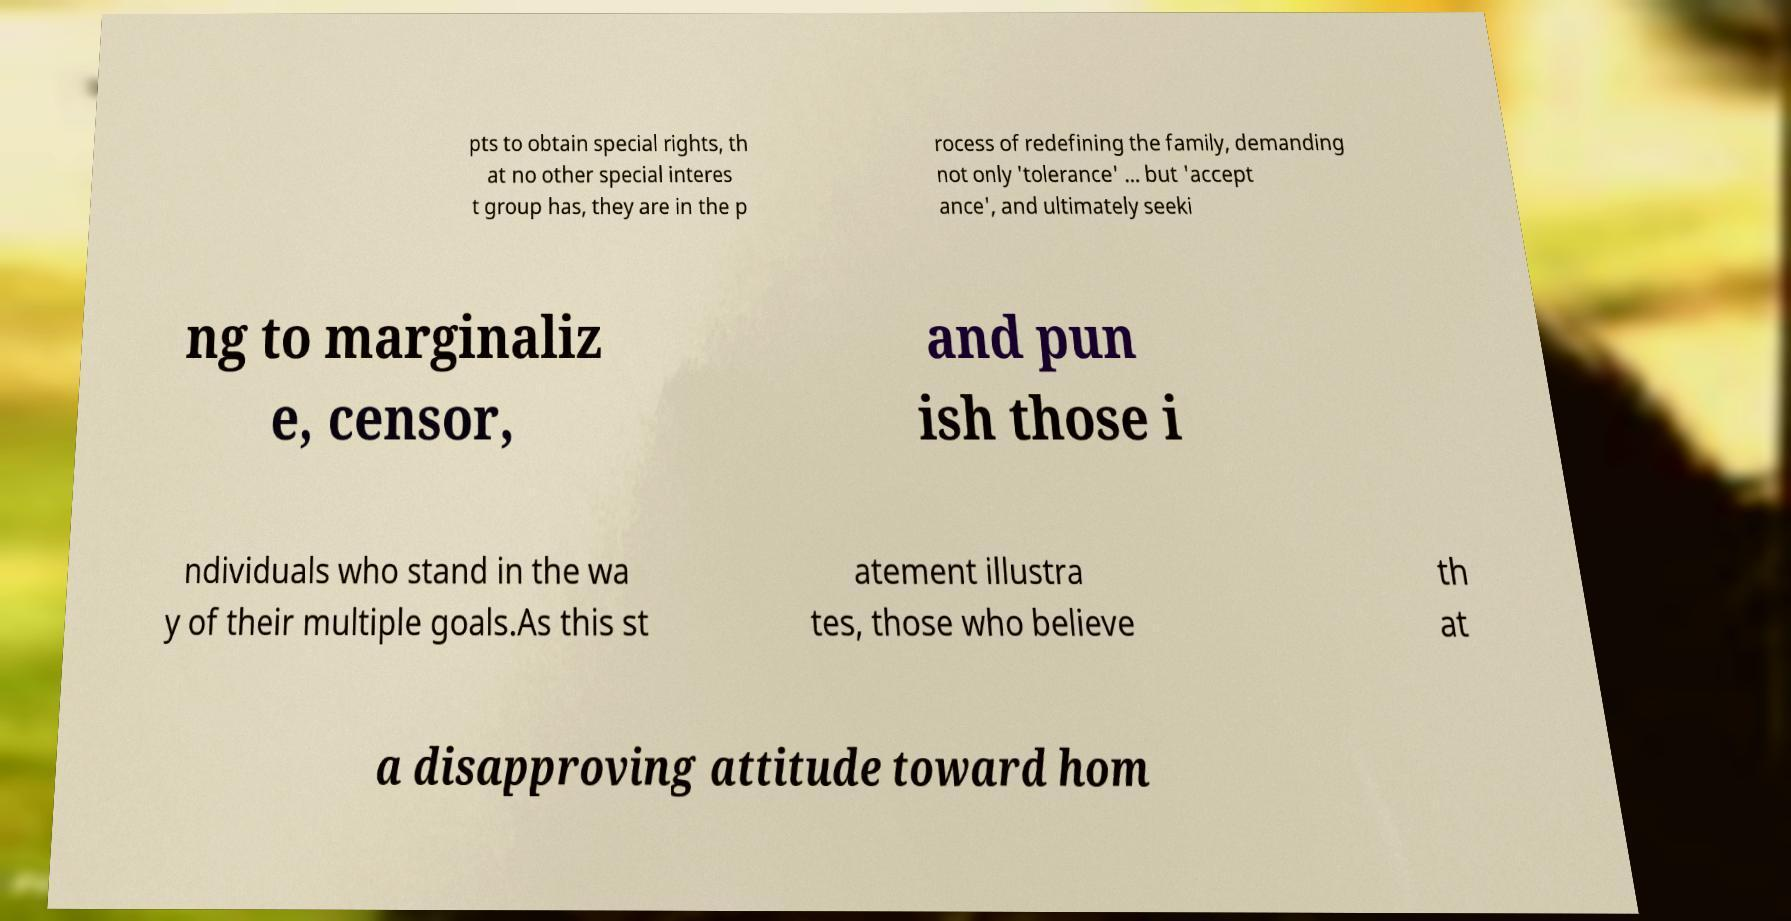Can you read and provide the text displayed in the image?This photo seems to have some interesting text. Can you extract and type it out for me? pts to obtain special rights, th at no other special interes t group has, they are in the p rocess of redefining the family, demanding not only 'tolerance' ... but 'accept ance', and ultimately seeki ng to marginaliz e, censor, and pun ish those i ndividuals who stand in the wa y of their multiple goals.As this st atement illustra tes, those who believe th at a disapproving attitude toward hom 